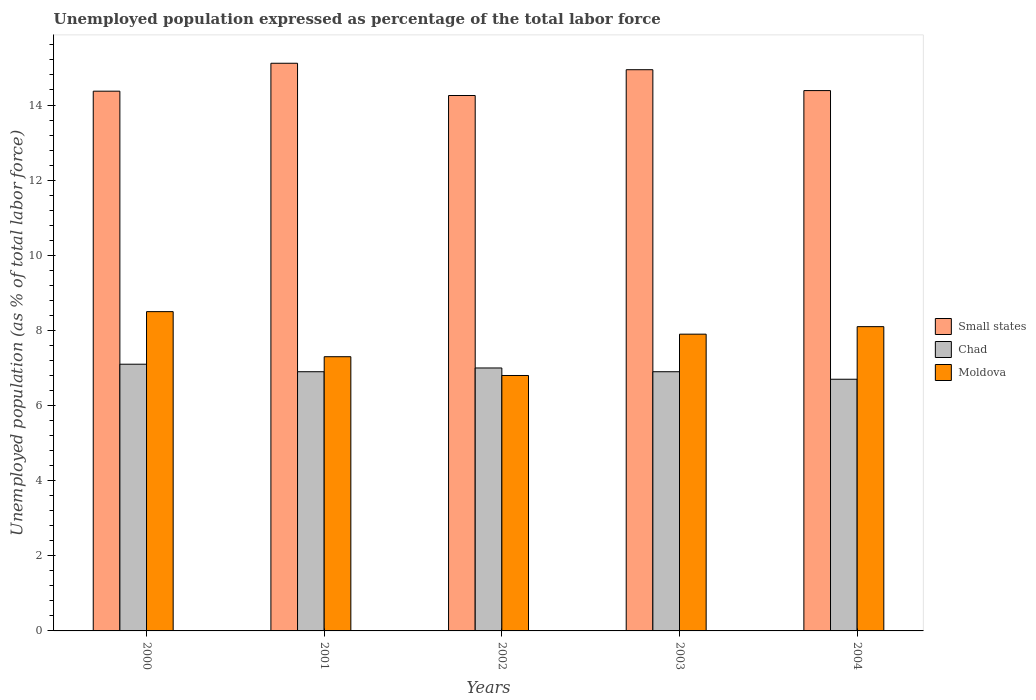How many groups of bars are there?
Keep it short and to the point. 5. Are the number of bars per tick equal to the number of legend labels?
Offer a very short reply. Yes. Are the number of bars on each tick of the X-axis equal?
Keep it short and to the point. Yes. How many bars are there on the 1st tick from the left?
Make the answer very short. 3. How many bars are there on the 3rd tick from the right?
Ensure brevity in your answer.  3. What is the label of the 4th group of bars from the left?
Your answer should be very brief. 2003. In how many cases, is the number of bars for a given year not equal to the number of legend labels?
Your response must be concise. 0. Across all years, what is the maximum unemployment in in Small states?
Offer a terse response. 15.11. Across all years, what is the minimum unemployment in in Moldova?
Make the answer very short. 6.8. What is the total unemployment in in Moldova in the graph?
Keep it short and to the point. 38.6. What is the difference between the unemployment in in Moldova in 2002 and that in 2003?
Offer a terse response. -1.1. What is the difference between the unemployment in in Moldova in 2003 and the unemployment in in Small states in 2004?
Provide a succinct answer. -6.48. What is the average unemployment in in Chad per year?
Your answer should be compact. 6.92. In the year 2004, what is the difference between the unemployment in in Small states and unemployment in in Chad?
Your response must be concise. 7.68. What is the ratio of the unemployment in in Chad in 2000 to that in 2003?
Provide a succinct answer. 1.03. Is the unemployment in in Chad in 2002 less than that in 2004?
Offer a terse response. No. What is the difference between the highest and the second highest unemployment in in Chad?
Your response must be concise. 0.1. What is the difference between the highest and the lowest unemployment in in Chad?
Keep it short and to the point. 0.4. In how many years, is the unemployment in in Moldova greater than the average unemployment in in Moldova taken over all years?
Your response must be concise. 3. What does the 3rd bar from the left in 2002 represents?
Ensure brevity in your answer.  Moldova. What does the 2nd bar from the right in 2001 represents?
Offer a very short reply. Chad. Are all the bars in the graph horizontal?
Provide a succinct answer. No. What is the difference between two consecutive major ticks on the Y-axis?
Offer a very short reply. 2. What is the title of the graph?
Ensure brevity in your answer.  Unemployed population expressed as percentage of the total labor force. What is the label or title of the Y-axis?
Keep it short and to the point. Unemployed population (as % of total labor force). What is the Unemployed population (as % of total labor force) in Small states in 2000?
Offer a terse response. 14.37. What is the Unemployed population (as % of total labor force) in Chad in 2000?
Your answer should be very brief. 7.1. What is the Unemployed population (as % of total labor force) in Small states in 2001?
Make the answer very short. 15.11. What is the Unemployed population (as % of total labor force) of Chad in 2001?
Your answer should be compact. 6.9. What is the Unemployed population (as % of total labor force) of Moldova in 2001?
Ensure brevity in your answer.  7.3. What is the Unemployed population (as % of total labor force) of Small states in 2002?
Ensure brevity in your answer.  14.25. What is the Unemployed population (as % of total labor force) of Moldova in 2002?
Make the answer very short. 6.8. What is the Unemployed population (as % of total labor force) in Small states in 2003?
Your response must be concise. 14.94. What is the Unemployed population (as % of total labor force) in Chad in 2003?
Your answer should be very brief. 6.9. What is the Unemployed population (as % of total labor force) in Moldova in 2003?
Keep it short and to the point. 7.9. What is the Unemployed population (as % of total labor force) of Small states in 2004?
Offer a very short reply. 14.38. What is the Unemployed population (as % of total labor force) of Chad in 2004?
Your answer should be very brief. 6.7. What is the Unemployed population (as % of total labor force) in Moldova in 2004?
Your answer should be compact. 8.1. Across all years, what is the maximum Unemployed population (as % of total labor force) in Small states?
Your response must be concise. 15.11. Across all years, what is the maximum Unemployed population (as % of total labor force) of Chad?
Your answer should be compact. 7.1. Across all years, what is the maximum Unemployed population (as % of total labor force) of Moldova?
Offer a terse response. 8.5. Across all years, what is the minimum Unemployed population (as % of total labor force) of Small states?
Offer a very short reply. 14.25. Across all years, what is the minimum Unemployed population (as % of total labor force) of Chad?
Offer a very short reply. 6.7. Across all years, what is the minimum Unemployed population (as % of total labor force) of Moldova?
Provide a succinct answer. 6.8. What is the total Unemployed population (as % of total labor force) of Small states in the graph?
Your response must be concise. 73.06. What is the total Unemployed population (as % of total labor force) in Chad in the graph?
Provide a short and direct response. 34.6. What is the total Unemployed population (as % of total labor force) in Moldova in the graph?
Your answer should be compact. 38.6. What is the difference between the Unemployed population (as % of total labor force) of Small states in 2000 and that in 2001?
Make the answer very short. -0.74. What is the difference between the Unemployed population (as % of total labor force) in Moldova in 2000 and that in 2001?
Give a very brief answer. 1.2. What is the difference between the Unemployed population (as % of total labor force) in Small states in 2000 and that in 2002?
Provide a succinct answer. 0.12. What is the difference between the Unemployed population (as % of total labor force) of Small states in 2000 and that in 2003?
Provide a short and direct response. -0.57. What is the difference between the Unemployed population (as % of total labor force) of Small states in 2000 and that in 2004?
Keep it short and to the point. -0.02. What is the difference between the Unemployed population (as % of total labor force) of Moldova in 2000 and that in 2004?
Offer a very short reply. 0.4. What is the difference between the Unemployed population (as % of total labor force) in Small states in 2001 and that in 2002?
Ensure brevity in your answer.  0.86. What is the difference between the Unemployed population (as % of total labor force) in Chad in 2001 and that in 2002?
Offer a terse response. -0.1. What is the difference between the Unemployed population (as % of total labor force) of Small states in 2001 and that in 2003?
Your answer should be compact. 0.17. What is the difference between the Unemployed population (as % of total labor force) in Chad in 2001 and that in 2003?
Your answer should be compact. 0. What is the difference between the Unemployed population (as % of total labor force) in Small states in 2001 and that in 2004?
Offer a terse response. 0.73. What is the difference between the Unemployed population (as % of total labor force) in Chad in 2001 and that in 2004?
Make the answer very short. 0.2. What is the difference between the Unemployed population (as % of total labor force) in Moldova in 2001 and that in 2004?
Offer a terse response. -0.8. What is the difference between the Unemployed population (as % of total labor force) in Small states in 2002 and that in 2003?
Ensure brevity in your answer.  -0.69. What is the difference between the Unemployed population (as % of total labor force) of Chad in 2002 and that in 2003?
Your response must be concise. 0.1. What is the difference between the Unemployed population (as % of total labor force) of Small states in 2002 and that in 2004?
Your answer should be very brief. -0.13. What is the difference between the Unemployed population (as % of total labor force) of Chad in 2002 and that in 2004?
Give a very brief answer. 0.3. What is the difference between the Unemployed population (as % of total labor force) in Small states in 2003 and that in 2004?
Offer a terse response. 0.56. What is the difference between the Unemployed population (as % of total labor force) in Chad in 2003 and that in 2004?
Your answer should be compact. 0.2. What is the difference between the Unemployed population (as % of total labor force) of Small states in 2000 and the Unemployed population (as % of total labor force) of Chad in 2001?
Offer a terse response. 7.47. What is the difference between the Unemployed population (as % of total labor force) of Small states in 2000 and the Unemployed population (as % of total labor force) of Moldova in 2001?
Provide a short and direct response. 7.07. What is the difference between the Unemployed population (as % of total labor force) of Chad in 2000 and the Unemployed population (as % of total labor force) of Moldova in 2001?
Give a very brief answer. -0.2. What is the difference between the Unemployed population (as % of total labor force) of Small states in 2000 and the Unemployed population (as % of total labor force) of Chad in 2002?
Your answer should be very brief. 7.37. What is the difference between the Unemployed population (as % of total labor force) of Small states in 2000 and the Unemployed population (as % of total labor force) of Moldova in 2002?
Provide a succinct answer. 7.57. What is the difference between the Unemployed population (as % of total labor force) of Chad in 2000 and the Unemployed population (as % of total labor force) of Moldova in 2002?
Your answer should be very brief. 0.3. What is the difference between the Unemployed population (as % of total labor force) of Small states in 2000 and the Unemployed population (as % of total labor force) of Chad in 2003?
Provide a short and direct response. 7.47. What is the difference between the Unemployed population (as % of total labor force) in Small states in 2000 and the Unemployed population (as % of total labor force) in Moldova in 2003?
Ensure brevity in your answer.  6.47. What is the difference between the Unemployed population (as % of total labor force) in Small states in 2000 and the Unemployed population (as % of total labor force) in Chad in 2004?
Make the answer very short. 7.67. What is the difference between the Unemployed population (as % of total labor force) in Small states in 2000 and the Unemployed population (as % of total labor force) in Moldova in 2004?
Give a very brief answer. 6.27. What is the difference between the Unemployed population (as % of total labor force) of Chad in 2000 and the Unemployed population (as % of total labor force) of Moldova in 2004?
Your answer should be very brief. -1. What is the difference between the Unemployed population (as % of total labor force) in Small states in 2001 and the Unemployed population (as % of total labor force) in Chad in 2002?
Provide a short and direct response. 8.11. What is the difference between the Unemployed population (as % of total labor force) in Small states in 2001 and the Unemployed population (as % of total labor force) in Moldova in 2002?
Provide a succinct answer. 8.31. What is the difference between the Unemployed population (as % of total labor force) of Small states in 2001 and the Unemployed population (as % of total labor force) of Chad in 2003?
Offer a terse response. 8.21. What is the difference between the Unemployed population (as % of total labor force) in Small states in 2001 and the Unemployed population (as % of total labor force) in Moldova in 2003?
Your answer should be very brief. 7.21. What is the difference between the Unemployed population (as % of total labor force) in Chad in 2001 and the Unemployed population (as % of total labor force) in Moldova in 2003?
Make the answer very short. -1. What is the difference between the Unemployed population (as % of total labor force) of Small states in 2001 and the Unemployed population (as % of total labor force) of Chad in 2004?
Offer a terse response. 8.41. What is the difference between the Unemployed population (as % of total labor force) in Small states in 2001 and the Unemployed population (as % of total labor force) in Moldova in 2004?
Give a very brief answer. 7.01. What is the difference between the Unemployed population (as % of total labor force) of Chad in 2001 and the Unemployed population (as % of total labor force) of Moldova in 2004?
Offer a very short reply. -1.2. What is the difference between the Unemployed population (as % of total labor force) in Small states in 2002 and the Unemployed population (as % of total labor force) in Chad in 2003?
Keep it short and to the point. 7.35. What is the difference between the Unemployed population (as % of total labor force) in Small states in 2002 and the Unemployed population (as % of total labor force) in Moldova in 2003?
Your response must be concise. 6.35. What is the difference between the Unemployed population (as % of total labor force) of Chad in 2002 and the Unemployed population (as % of total labor force) of Moldova in 2003?
Give a very brief answer. -0.9. What is the difference between the Unemployed population (as % of total labor force) of Small states in 2002 and the Unemployed population (as % of total labor force) of Chad in 2004?
Your answer should be very brief. 7.55. What is the difference between the Unemployed population (as % of total labor force) of Small states in 2002 and the Unemployed population (as % of total labor force) of Moldova in 2004?
Offer a very short reply. 6.15. What is the difference between the Unemployed population (as % of total labor force) in Chad in 2002 and the Unemployed population (as % of total labor force) in Moldova in 2004?
Your answer should be very brief. -1.1. What is the difference between the Unemployed population (as % of total labor force) in Small states in 2003 and the Unemployed population (as % of total labor force) in Chad in 2004?
Offer a terse response. 8.24. What is the difference between the Unemployed population (as % of total labor force) of Small states in 2003 and the Unemployed population (as % of total labor force) of Moldova in 2004?
Make the answer very short. 6.84. What is the difference between the Unemployed population (as % of total labor force) of Chad in 2003 and the Unemployed population (as % of total labor force) of Moldova in 2004?
Offer a very short reply. -1.2. What is the average Unemployed population (as % of total labor force) in Small states per year?
Provide a short and direct response. 14.61. What is the average Unemployed population (as % of total labor force) of Chad per year?
Ensure brevity in your answer.  6.92. What is the average Unemployed population (as % of total labor force) in Moldova per year?
Your response must be concise. 7.72. In the year 2000, what is the difference between the Unemployed population (as % of total labor force) of Small states and Unemployed population (as % of total labor force) of Chad?
Offer a very short reply. 7.27. In the year 2000, what is the difference between the Unemployed population (as % of total labor force) in Small states and Unemployed population (as % of total labor force) in Moldova?
Make the answer very short. 5.87. In the year 2000, what is the difference between the Unemployed population (as % of total labor force) of Chad and Unemployed population (as % of total labor force) of Moldova?
Provide a succinct answer. -1.4. In the year 2001, what is the difference between the Unemployed population (as % of total labor force) of Small states and Unemployed population (as % of total labor force) of Chad?
Give a very brief answer. 8.21. In the year 2001, what is the difference between the Unemployed population (as % of total labor force) in Small states and Unemployed population (as % of total labor force) in Moldova?
Offer a very short reply. 7.81. In the year 2002, what is the difference between the Unemployed population (as % of total labor force) in Small states and Unemployed population (as % of total labor force) in Chad?
Give a very brief answer. 7.25. In the year 2002, what is the difference between the Unemployed population (as % of total labor force) of Small states and Unemployed population (as % of total labor force) of Moldova?
Provide a succinct answer. 7.45. In the year 2002, what is the difference between the Unemployed population (as % of total labor force) in Chad and Unemployed population (as % of total labor force) in Moldova?
Keep it short and to the point. 0.2. In the year 2003, what is the difference between the Unemployed population (as % of total labor force) of Small states and Unemployed population (as % of total labor force) of Chad?
Make the answer very short. 8.04. In the year 2003, what is the difference between the Unemployed population (as % of total labor force) of Small states and Unemployed population (as % of total labor force) of Moldova?
Provide a succinct answer. 7.04. In the year 2004, what is the difference between the Unemployed population (as % of total labor force) in Small states and Unemployed population (as % of total labor force) in Chad?
Provide a succinct answer. 7.68. In the year 2004, what is the difference between the Unemployed population (as % of total labor force) in Small states and Unemployed population (as % of total labor force) in Moldova?
Provide a short and direct response. 6.28. In the year 2004, what is the difference between the Unemployed population (as % of total labor force) of Chad and Unemployed population (as % of total labor force) of Moldova?
Provide a succinct answer. -1.4. What is the ratio of the Unemployed population (as % of total labor force) in Small states in 2000 to that in 2001?
Your answer should be very brief. 0.95. What is the ratio of the Unemployed population (as % of total labor force) in Moldova in 2000 to that in 2001?
Ensure brevity in your answer.  1.16. What is the ratio of the Unemployed population (as % of total labor force) of Chad in 2000 to that in 2002?
Your response must be concise. 1.01. What is the ratio of the Unemployed population (as % of total labor force) of Moldova in 2000 to that in 2002?
Offer a terse response. 1.25. What is the ratio of the Unemployed population (as % of total labor force) in Small states in 2000 to that in 2003?
Your response must be concise. 0.96. What is the ratio of the Unemployed population (as % of total labor force) of Chad in 2000 to that in 2003?
Make the answer very short. 1.03. What is the ratio of the Unemployed population (as % of total labor force) of Moldova in 2000 to that in 2003?
Make the answer very short. 1.08. What is the ratio of the Unemployed population (as % of total labor force) in Small states in 2000 to that in 2004?
Offer a terse response. 1. What is the ratio of the Unemployed population (as % of total labor force) of Chad in 2000 to that in 2004?
Your response must be concise. 1.06. What is the ratio of the Unemployed population (as % of total labor force) in Moldova in 2000 to that in 2004?
Ensure brevity in your answer.  1.05. What is the ratio of the Unemployed population (as % of total labor force) in Small states in 2001 to that in 2002?
Your answer should be compact. 1.06. What is the ratio of the Unemployed population (as % of total labor force) of Chad in 2001 to that in 2002?
Keep it short and to the point. 0.99. What is the ratio of the Unemployed population (as % of total labor force) in Moldova in 2001 to that in 2002?
Your response must be concise. 1.07. What is the ratio of the Unemployed population (as % of total labor force) of Small states in 2001 to that in 2003?
Provide a short and direct response. 1.01. What is the ratio of the Unemployed population (as % of total labor force) of Chad in 2001 to that in 2003?
Ensure brevity in your answer.  1. What is the ratio of the Unemployed population (as % of total labor force) of Moldova in 2001 to that in 2003?
Ensure brevity in your answer.  0.92. What is the ratio of the Unemployed population (as % of total labor force) in Small states in 2001 to that in 2004?
Offer a terse response. 1.05. What is the ratio of the Unemployed population (as % of total labor force) of Chad in 2001 to that in 2004?
Offer a very short reply. 1.03. What is the ratio of the Unemployed population (as % of total labor force) of Moldova in 2001 to that in 2004?
Your answer should be very brief. 0.9. What is the ratio of the Unemployed population (as % of total labor force) in Small states in 2002 to that in 2003?
Make the answer very short. 0.95. What is the ratio of the Unemployed population (as % of total labor force) of Chad in 2002 to that in 2003?
Offer a terse response. 1.01. What is the ratio of the Unemployed population (as % of total labor force) in Moldova in 2002 to that in 2003?
Provide a succinct answer. 0.86. What is the ratio of the Unemployed population (as % of total labor force) of Small states in 2002 to that in 2004?
Provide a short and direct response. 0.99. What is the ratio of the Unemployed population (as % of total labor force) in Chad in 2002 to that in 2004?
Ensure brevity in your answer.  1.04. What is the ratio of the Unemployed population (as % of total labor force) in Moldova in 2002 to that in 2004?
Your answer should be very brief. 0.84. What is the ratio of the Unemployed population (as % of total labor force) in Small states in 2003 to that in 2004?
Offer a very short reply. 1.04. What is the ratio of the Unemployed population (as % of total labor force) in Chad in 2003 to that in 2004?
Make the answer very short. 1.03. What is the ratio of the Unemployed population (as % of total labor force) in Moldova in 2003 to that in 2004?
Offer a terse response. 0.98. What is the difference between the highest and the second highest Unemployed population (as % of total labor force) in Small states?
Ensure brevity in your answer.  0.17. What is the difference between the highest and the second highest Unemployed population (as % of total labor force) of Chad?
Offer a terse response. 0.1. What is the difference between the highest and the second highest Unemployed population (as % of total labor force) of Moldova?
Your answer should be compact. 0.4. What is the difference between the highest and the lowest Unemployed population (as % of total labor force) in Small states?
Make the answer very short. 0.86. What is the difference between the highest and the lowest Unemployed population (as % of total labor force) of Chad?
Give a very brief answer. 0.4. 